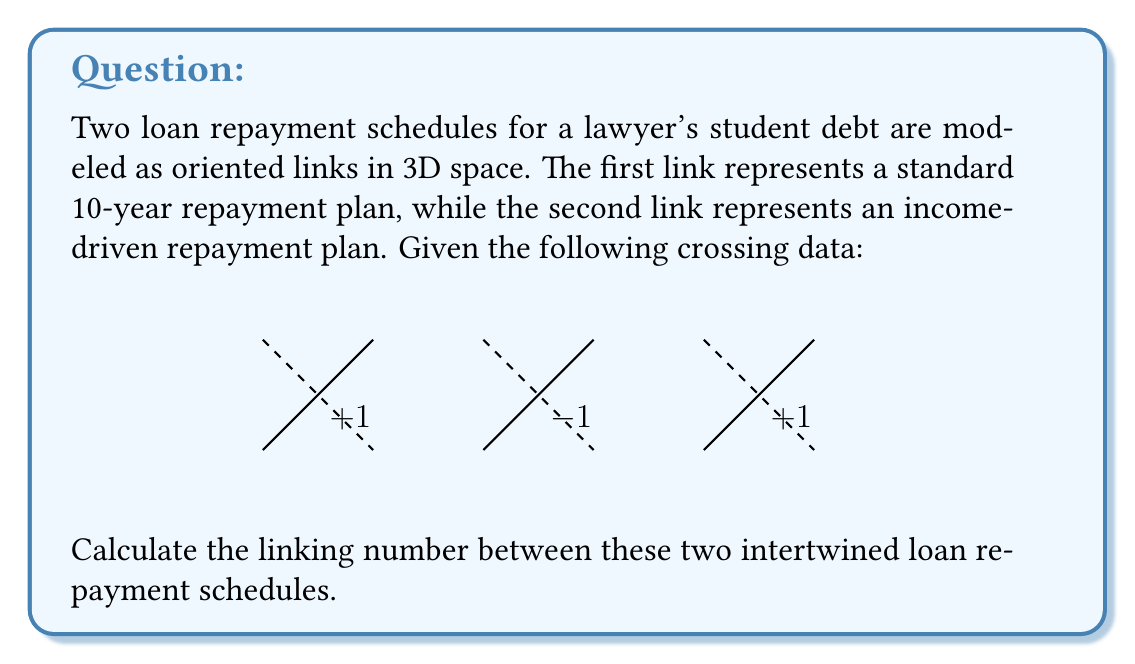Help me with this question. To calculate the linking number between two oriented links, we follow these steps:

1) Identify the crossings where one link passes over the other.
2) Assign a value of +1 or -1 to each crossing based on the right-hand rule:
   - If the overlying segment's direction and the underlying segment's direction form a right-handed screw, assign +1.
   - If they form a left-handed screw, assign -1.
3) Sum these values and divide by 2 to get the linking number.

In this case:

1) We have three crossings where one link passes over the other.

2) Assigning values:
   - First crossing: +1
   - Second crossing: -1
   - Third crossing: +1

3) Calculating the linking number:

   $$ \text{Linking Number} = \frac{1}{2} \sum \text{Crossing Values} $$
   $$ = \frac{1}{2} (+1 + (-1) + (+1)) $$
   $$ = \frac{1}{2} (1) $$
   $$ = \frac{1}{2} $$

The linking number of 1/2 indicates that the two loan repayment schedules are linked and cannot be separated without cutting one of them. This could represent how the choice of repayment plan (standard or income-driven) affects the overall debt repayment strategy, and how these choices are intertwined throughout the lawyer's career.
Answer: $\frac{1}{2}$ 